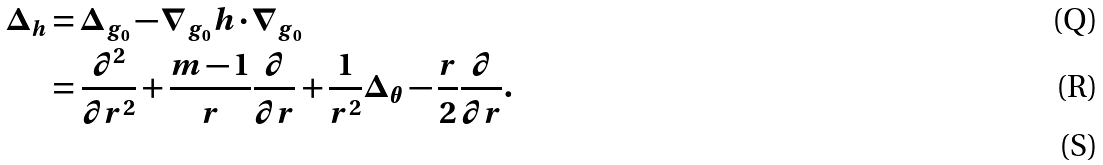<formula> <loc_0><loc_0><loc_500><loc_500>\Delta _ { h } & = \Delta _ { g _ { 0 } } - \nabla _ { g _ { 0 } } h \cdot \nabla _ { g _ { 0 } } \\ & = \frac { \partial ^ { 2 } } { \partial r ^ { 2 } } + \frac { m - 1 } { r } \frac { \partial } { \partial r } + \frac { 1 } { r ^ { 2 } } \Delta _ { \theta } - \frac { r } { 2 } \frac { \partial } { \partial r } . \\</formula> 